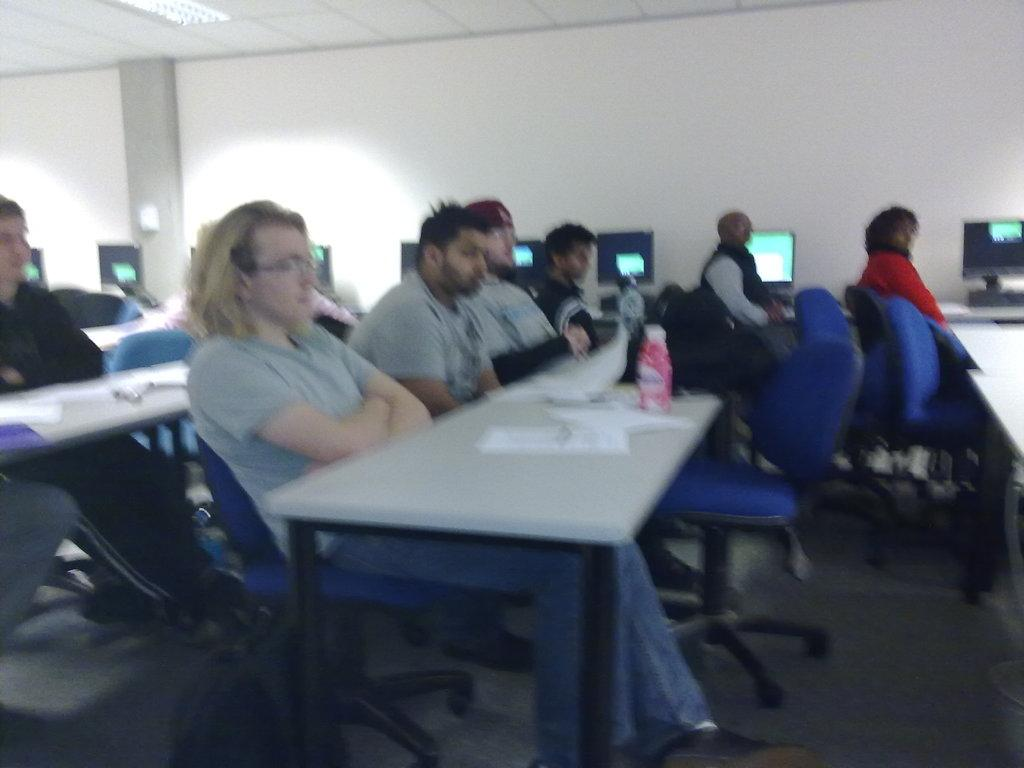How many people are in the image? There are a few people in the image. What are the people doing in the image? The people are sitting on chairs. What might the people be observing in the image? The people are observing something, but it is not specified what they are observing. How long does it take for the band to play a minute in the image? There is no band present in the image, so it is not possible to answer that question. 